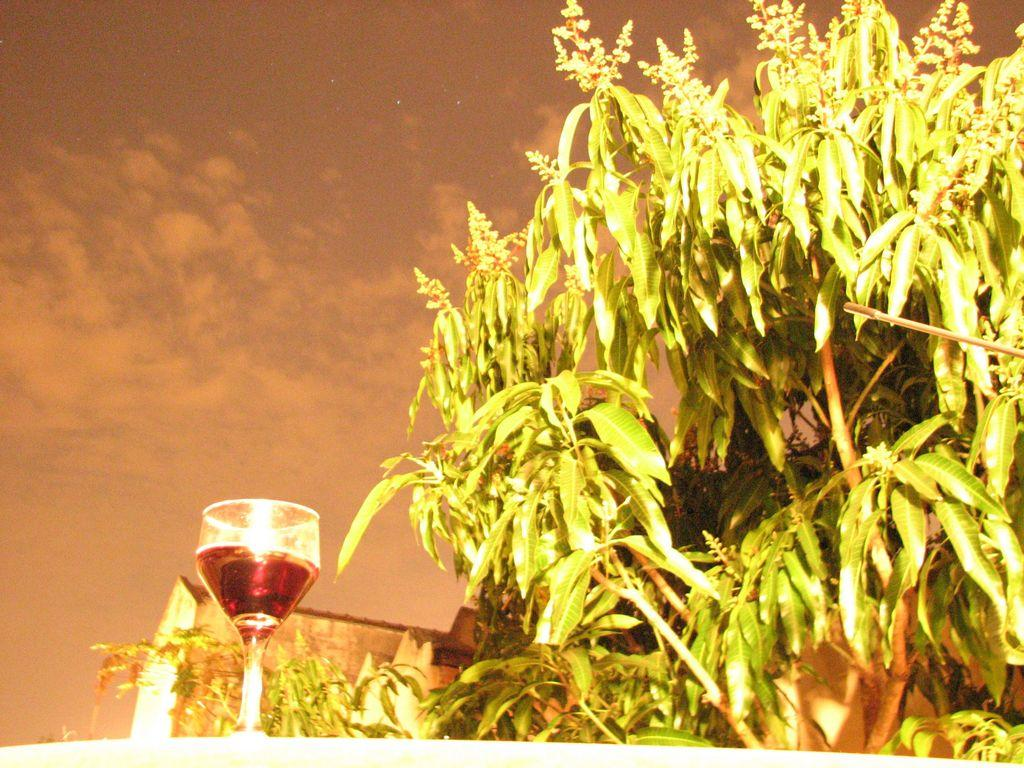What type of vegetation is on the right side of the image? There is a tree on the right side of the image. What object is on the left side of the image? There is a glass on the left side of the image. What can be seen in the sky at the top of the image? Clouds are present in the sky at the top of the image. What type of stone is being used to produce wool in the image? There is no stone or wool present in the image; it features a tree on the right side and a glass on the left side, with clouds in the sky at the top. 